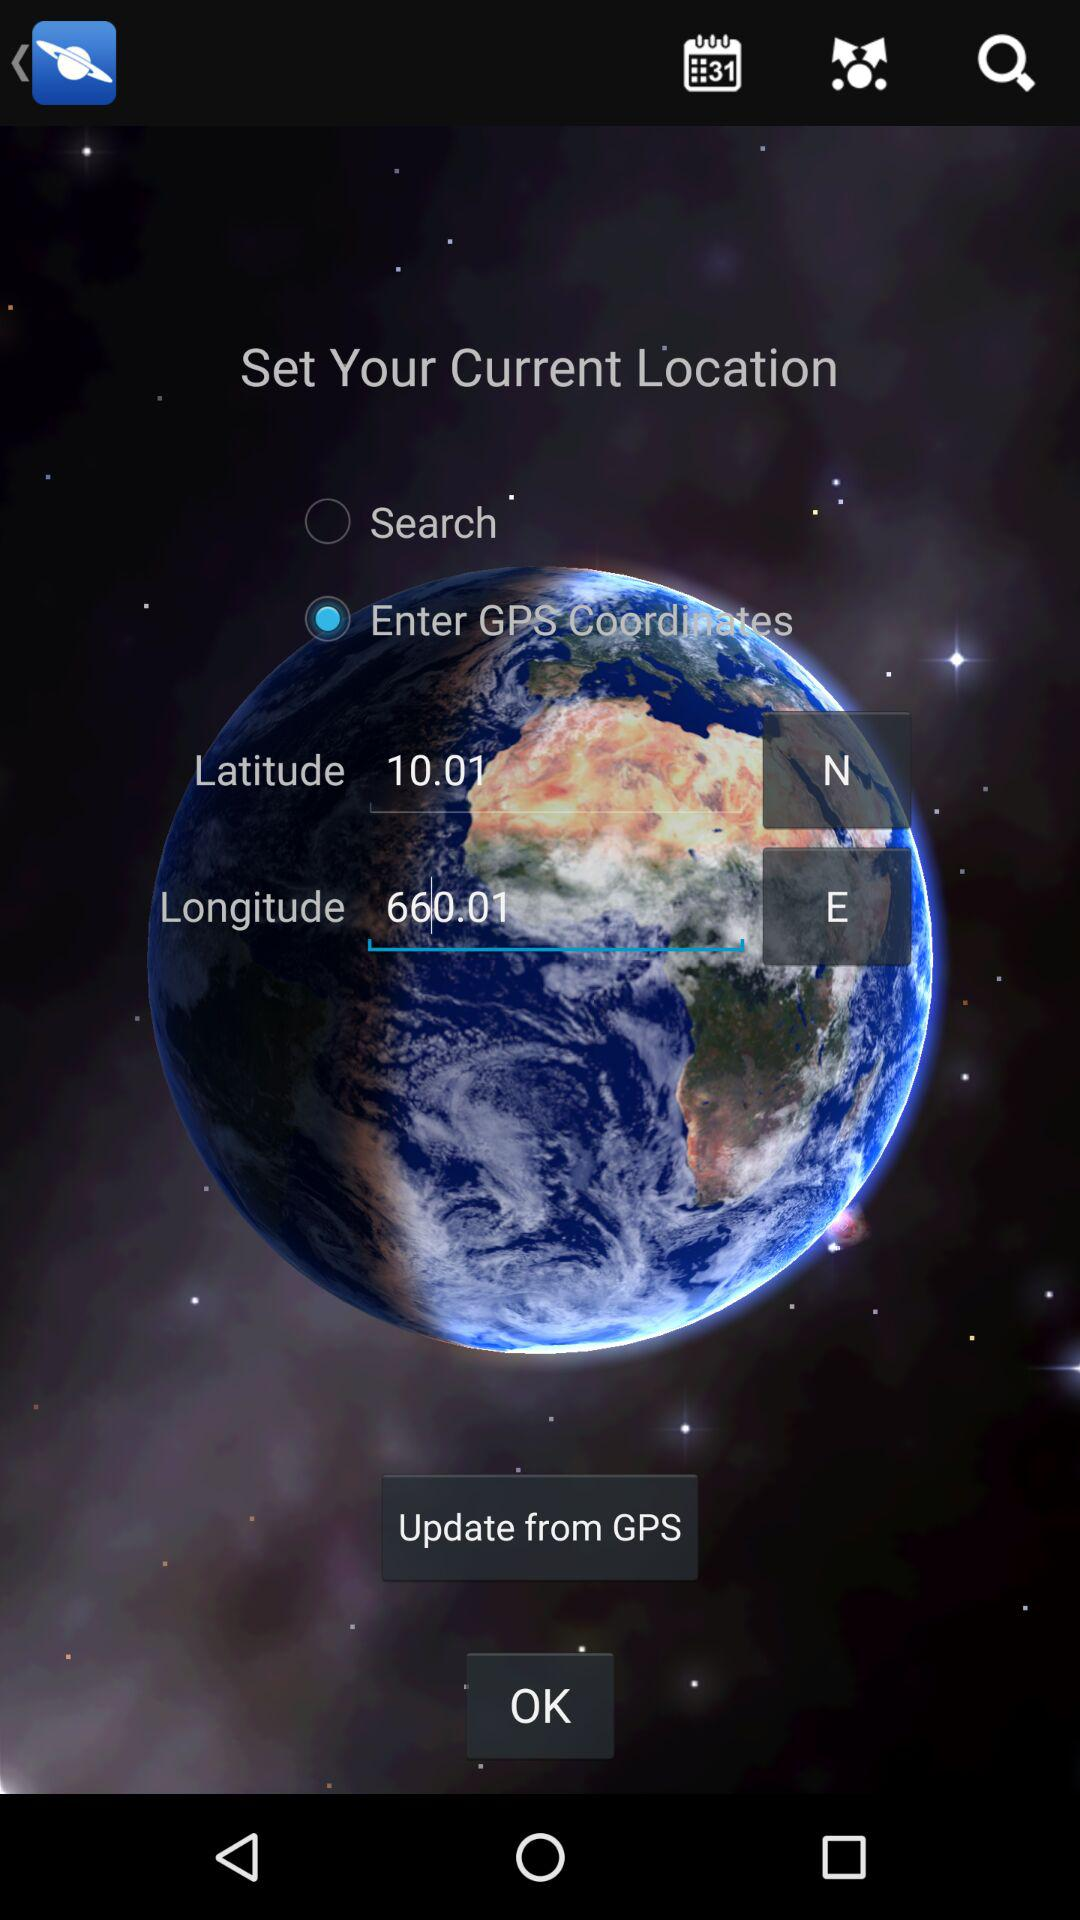What are the latitude and longitude coordinates entered on the screen? The entered latitude and longitude coordinates are 10.01 N and 660.01 E. 